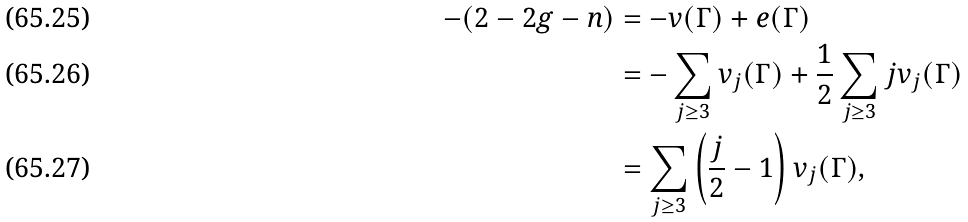Convert formula to latex. <formula><loc_0><loc_0><loc_500><loc_500>- ( 2 - 2 g - n ) & = - v ( \Gamma ) + e ( \Gamma ) \\ & = - \sum _ { j \geq 3 } v _ { j } ( \Gamma ) + \frac { 1 } { 2 } \sum _ { j \geq 3 } j v _ { j } ( \Gamma ) \\ & = \sum _ { j \geq 3 } \left ( \frac { j } { 2 } - 1 \right ) v _ { j } ( \Gamma ) ,</formula> 